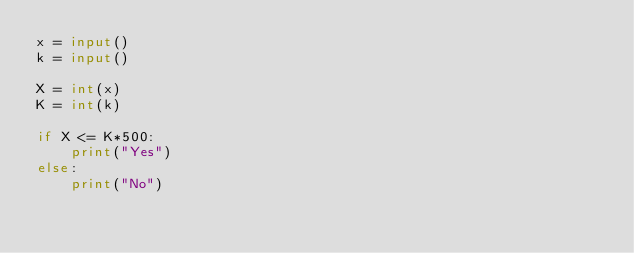<code> <loc_0><loc_0><loc_500><loc_500><_Python_>x = input()
k = input()

X = int(x)
K = int(k)

if X <= K*500:
    print("Yes")
else:
    print("No")</code> 